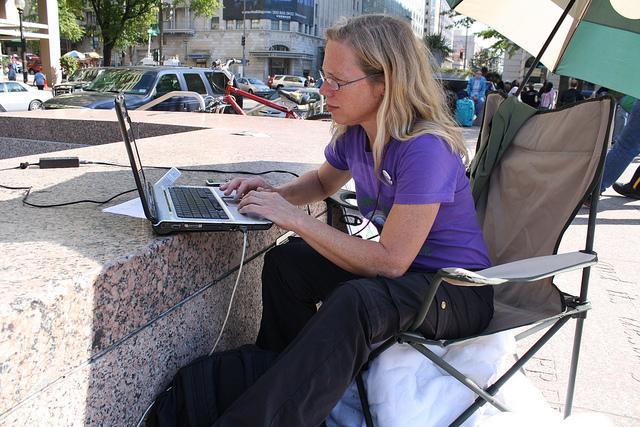Why is she working here? nice weather 